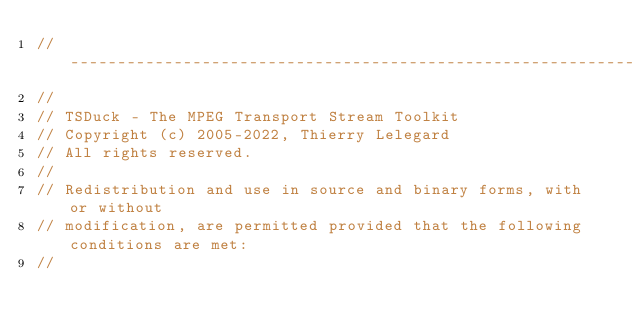<code> <loc_0><loc_0><loc_500><loc_500><_C_>//----------------------------------------------------------------------------
//
// TSDuck - The MPEG Transport Stream Toolkit
// Copyright (c) 2005-2022, Thierry Lelegard
// All rights reserved.
//
// Redistribution and use in source and binary forms, with or without
// modification, are permitted provided that the following conditions are met:
//</code> 